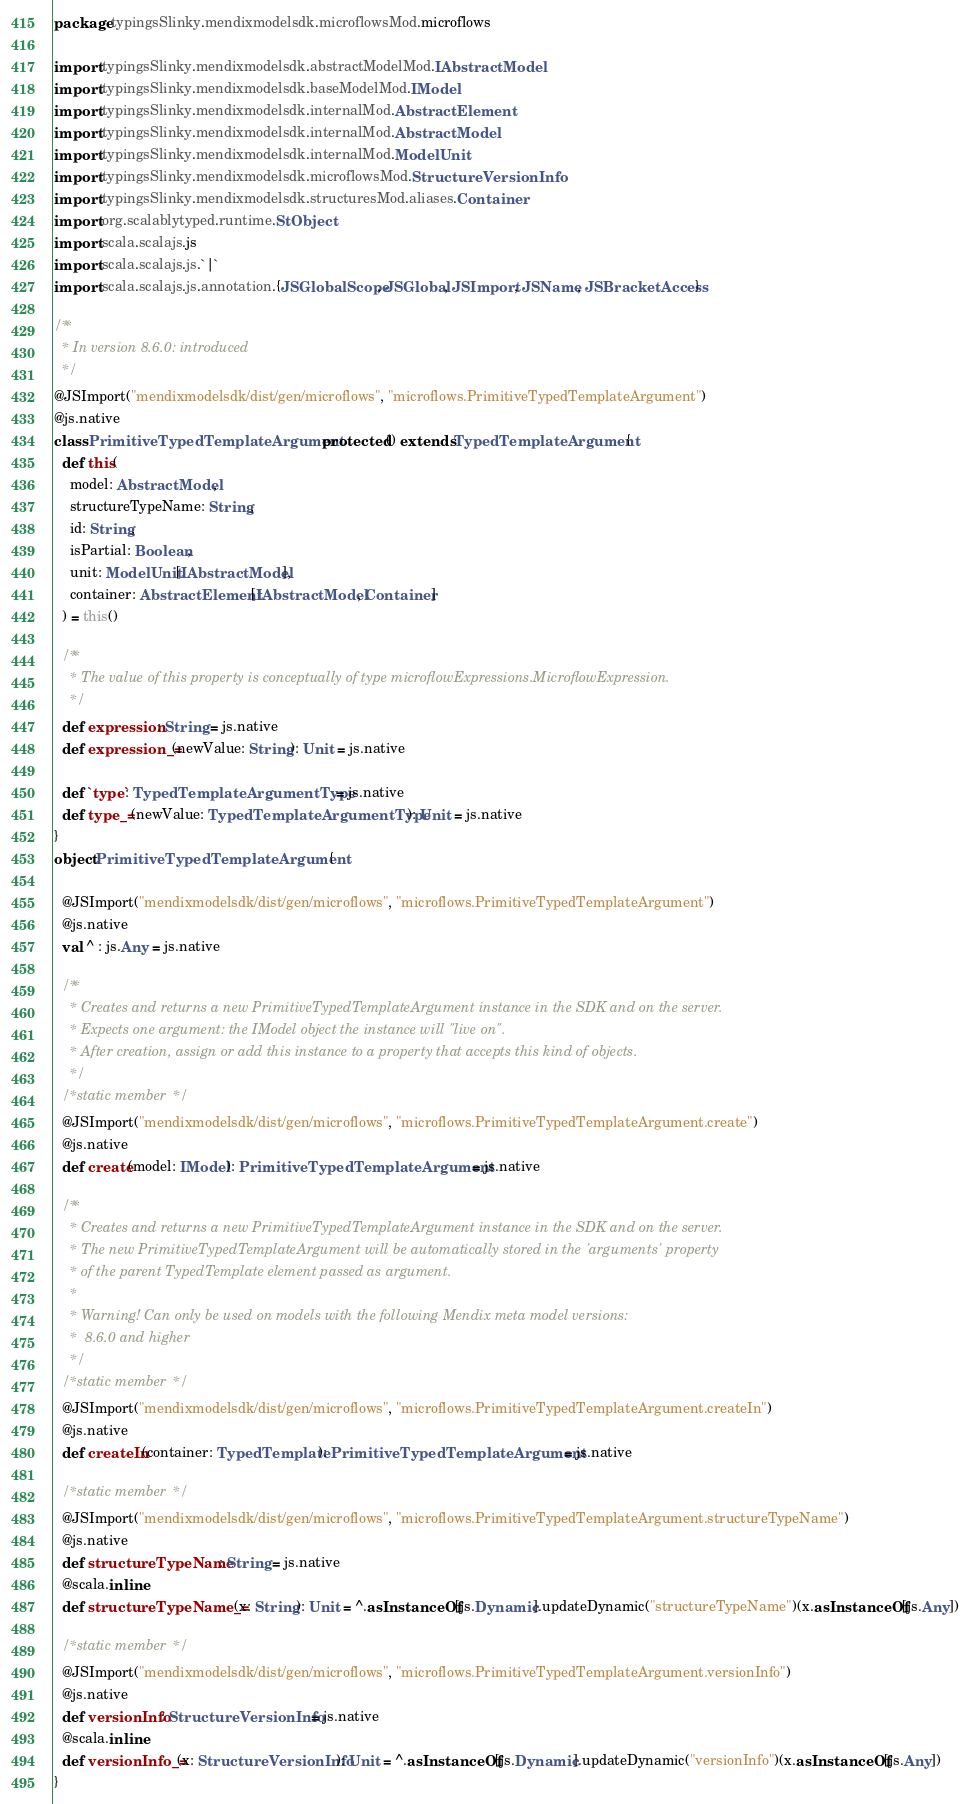Convert code to text. <code><loc_0><loc_0><loc_500><loc_500><_Scala_>package typingsSlinky.mendixmodelsdk.microflowsMod.microflows

import typingsSlinky.mendixmodelsdk.abstractModelMod.IAbstractModel
import typingsSlinky.mendixmodelsdk.baseModelMod.IModel
import typingsSlinky.mendixmodelsdk.internalMod.AbstractElement
import typingsSlinky.mendixmodelsdk.internalMod.AbstractModel
import typingsSlinky.mendixmodelsdk.internalMod.ModelUnit
import typingsSlinky.mendixmodelsdk.microflowsMod.StructureVersionInfo
import typingsSlinky.mendixmodelsdk.structuresMod.aliases.Container
import org.scalablytyped.runtime.StObject
import scala.scalajs.js
import scala.scalajs.js.`|`
import scala.scalajs.js.annotation.{JSGlobalScope, JSGlobal, JSImport, JSName, JSBracketAccess}

/**
  * In version 8.6.0: introduced
  */
@JSImport("mendixmodelsdk/dist/gen/microflows", "microflows.PrimitiveTypedTemplateArgument")
@js.native
class PrimitiveTypedTemplateArgument protected () extends TypedTemplateArgument {
  def this(
    model: AbstractModel,
    structureTypeName: String,
    id: String,
    isPartial: Boolean,
    unit: ModelUnit[IAbstractModel],
    container: AbstractElement[IAbstractModel, Container]
  ) = this()
  
  /**
    * The value of this property is conceptually of type microflowExpressions.MicroflowExpression.
    */
  def expression: String = js.native
  def expression_=(newValue: String): Unit = js.native
  
  def `type`: TypedTemplateArgumentType = js.native
  def type_=(newValue: TypedTemplateArgumentType): Unit = js.native
}
object PrimitiveTypedTemplateArgument {
  
  @JSImport("mendixmodelsdk/dist/gen/microflows", "microflows.PrimitiveTypedTemplateArgument")
  @js.native
  val ^ : js.Any = js.native
  
  /**
    * Creates and returns a new PrimitiveTypedTemplateArgument instance in the SDK and on the server.
    * Expects one argument: the IModel object the instance will "live on".
    * After creation, assign or add this instance to a property that accepts this kind of objects.
    */
  /* static member */
  @JSImport("mendixmodelsdk/dist/gen/microflows", "microflows.PrimitiveTypedTemplateArgument.create")
  @js.native
  def create(model: IModel): PrimitiveTypedTemplateArgument = js.native
  
  /**
    * Creates and returns a new PrimitiveTypedTemplateArgument instance in the SDK and on the server.
    * The new PrimitiveTypedTemplateArgument will be automatically stored in the 'arguments' property
    * of the parent TypedTemplate element passed as argument.
    *
    * Warning! Can only be used on models with the following Mendix meta model versions:
    *  8.6.0 and higher
    */
  /* static member */
  @JSImport("mendixmodelsdk/dist/gen/microflows", "microflows.PrimitiveTypedTemplateArgument.createIn")
  @js.native
  def createIn(container: TypedTemplate): PrimitiveTypedTemplateArgument = js.native
  
  /* static member */
  @JSImport("mendixmodelsdk/dist/gen/microflows", "microflows.PrimitiveTypedTemplateArgument.structureTypeName")
  @js.native
  def structureTypeName: String = js.native
  @scala.inline
  def structureTypeName_=(x: String): Unit = ^.asInstanceOf[js.Dynamic].updateDynamic("structureTypeName")(x.asInstanceOf[js.Any])
  
  /* static member */
  @JSImport("mendixmodelsdk/dist/gen/microflows", "microflows.PrimitiveTypedTemplateArgument.versionInfo")
  @js.native
  def versionInfo: StructureVersionInfo = js.native
  @scala.inline
  def versionInfo_=(x: StructureVersionInfo): Unit = ^.asInstanceOf[js.Dynamic].updateDynamic("versionInfo")(x.asInstanceOf[js.Any])
}
</code> 